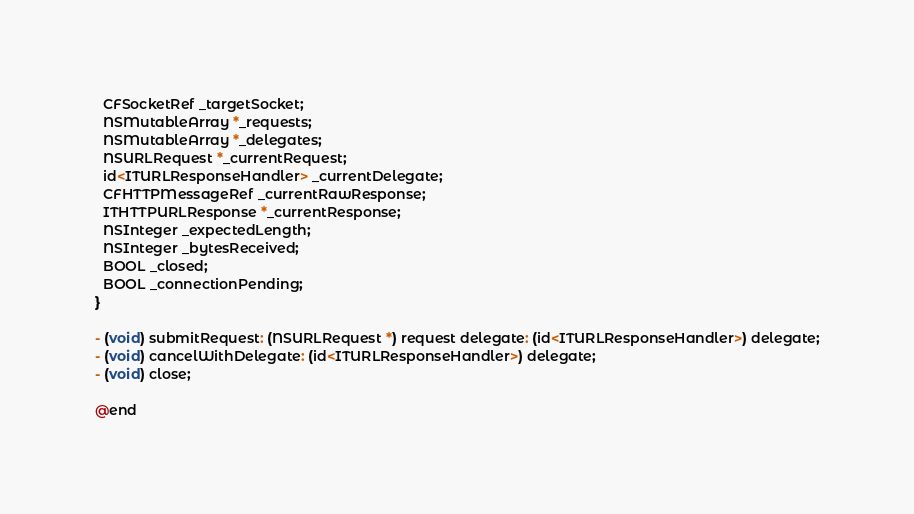Convert code to text. <code><loc_0><loc_0><loc_500><loc_500><_C_>  CFSocketRef _targetSocket;
  NSMutableArray *_requests;
  NSMutableArray *_delegates;
  NSURLRequest *_currentRequest;
  id<ITURLResponseHandler> _currentDelegate;
  CFHTTPMessageRef _currentRawResponse;
  ITHTTPURLResponse *_currentResponse;
  NSInteger _expectedLength;
  NSInteger _bytesReceived;
  BOOL _closed;
  BOOL _connectionPending;
}

- (void) submitRequest: (NSURLRequest *) request delegate: (id<ITURLResponseHandler>) delegate;
- (void) cancelWithDelegate: (id<ITURLResponseHandler>) delegate;
- (void) close;

@end
</code> 